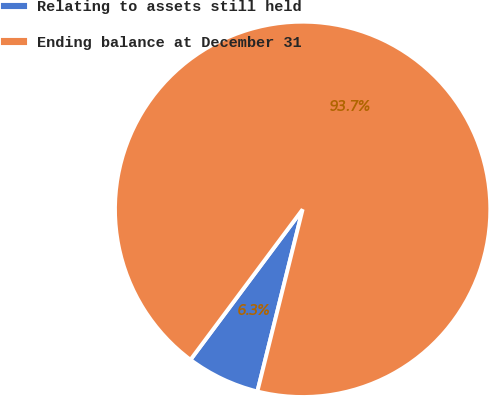Convert chart. <chart><loc_0><loc_0><loc_500><loc_500><pie_chart><fcel>Relating to assets still held<fcel>Ending balance at December 31<nl><fcel>6.32%<fcel>93.68%<nl></chart> 